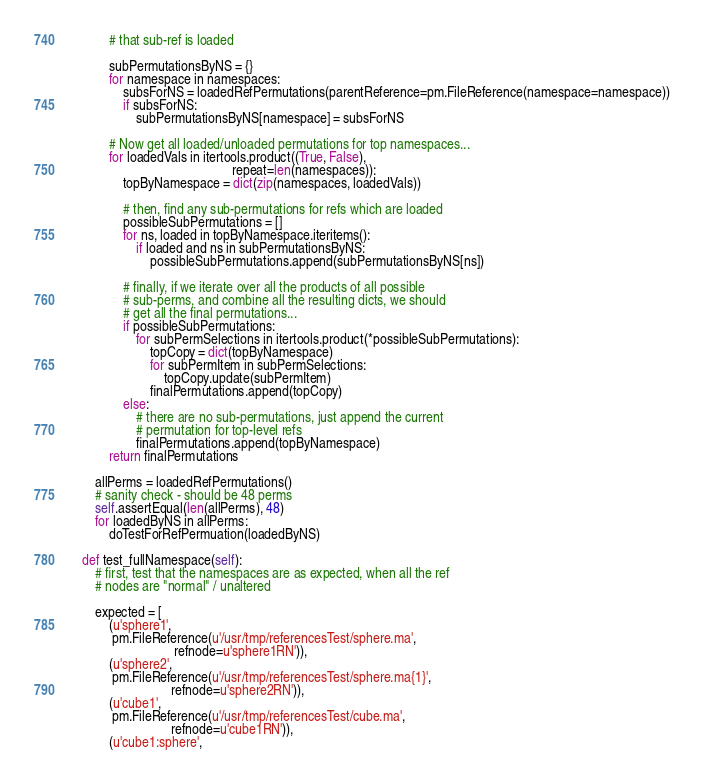<code> <loc_0><loc_0><loc_500><loc_500><_Python_>            # that sub-ref is loaded

            subPermutationsByNS = {}
            for namespace in namespaces:
                subsForNS = loadedRefPermutations(parentReference=pm.FileReference(namespace=namespace))
                if subsForNS:
                    subPermutationsByNS[namespace] = subsForNS

            # Now get all loaded/unloaded permutations for top namespaces...
            for loadedVals in itertools.product((True, False),
                                                repeat=len(namespaces)):
                topByNamespace = dict(zip(namespaces, loadedVals))

                # then, find any sub-permutations for refs which are loaded
                possibleSubPermutations = []
                for ns, loaded in topByNamespace.iteritems():
                    if loaded and ns in subPermutationsByNS:
                        possibleSubPermutations.append(subPermutationsByNS[ns])

                # finally, if we iterate over all the products of all possible
                # sub-perms, and combine all the resulting dicts, we should
                # get all the final permutations...
                if possibleSubPermutations:
                    for subPermSelections in itertools.product(*possibleSubPermutations):
                        topCopy = dict(topByNamespace)
                        for subPermItem in subPermSelections:
                            topCopy.update(subPermItem)
                        finalPermutations.append(topCopy)
                else:
                    # there are no sub-permutations, just append the current
                    # permutation for top-level refs
                    finalPermutations.append(topByNamespace)
            return finalPermutations

        allPerms = loadedRefPermutations()
        # sanity check - should be 48 perms
        self.assertEqual(len(allPerms), 48)
        for loadedByNS in allPerms:
            doTestForRefPermuation(loadedByNS)

    def test_fullNamespace(self):
        # first, test that the namespaces are as expected, when all the ref
        # nodes are "normal" / unaltered

        expected = [
            (u'sphere1',
             pm.FileReference(u'/usr/tmp/referencesTest/sphere.ma',
                               refnode=u'sphere1RN')),
            (u'sphere2',
             pm.FileReference(u'/usr/tmp/referencesTest/sphere.ma{1}',
                              refnode=u'sphere2RN')),
            (u'cube1',
             pm.FileReference(u'/usr/tmp/referencesTest/cube.ma',
                              refnode=u'cube1RN')),
            (u'cube1:sphere',</code> 